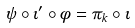Convert formula to latex. <formula><loc_0><loc_0><loc_500><loc_500>\psi \circ \iota ^ { \prime } \circ \phi = \pi _ { k } \circ \iota</formula> 